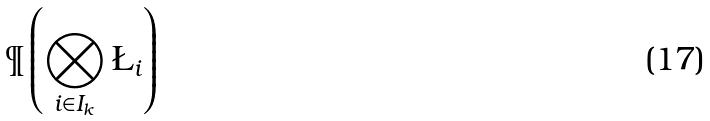Convert formula to latex. <formula><loc_0><loc_0><loc_500><loc_500>\P \left ( \bigotimes _ { i \in I _ { k } } \L _ { i } \right )</formula> 